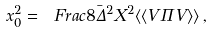<formula> <loc_0><loc_0><loc_500><loc_500>x _ { 0 } ^ { 2 } = \ F r a c { 8 } { \bar { \Delta } ^ { 2 } } X ^ { 2 } \langle \langle V \Pi V \rangle \rangle \, ,</formula> 